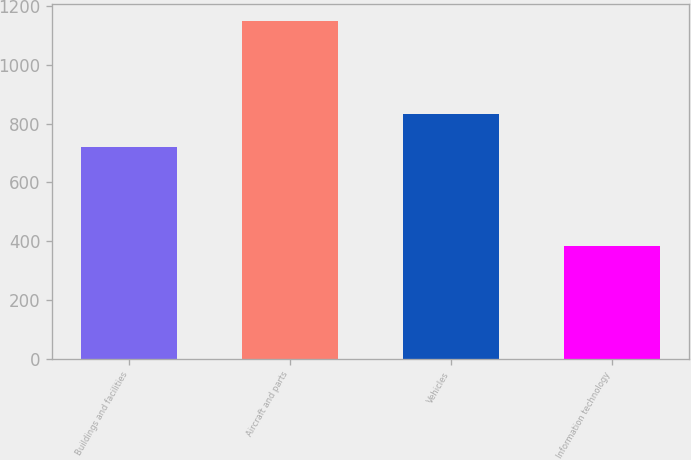Convert chart to OTSL. <chart><loc_0><loc_0><loc_500><loc_500><bar_chart><fcel>Buildings and facilities<fcel>Aircraft and parts<fcel>Vehicles<fcel>Information technology<nl><fcel>720<fcel>1150<fcel>831<fcel>384<nl></chart> 